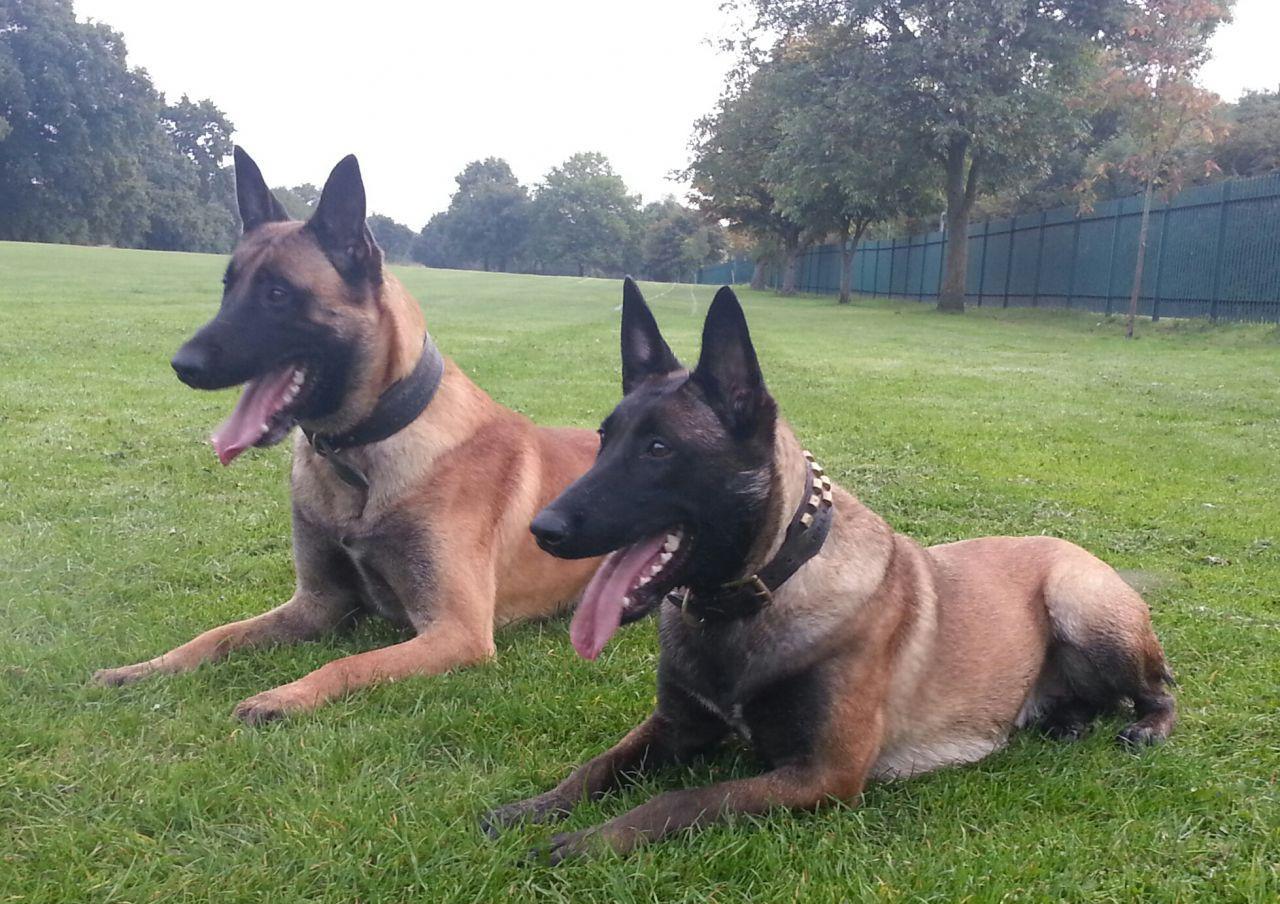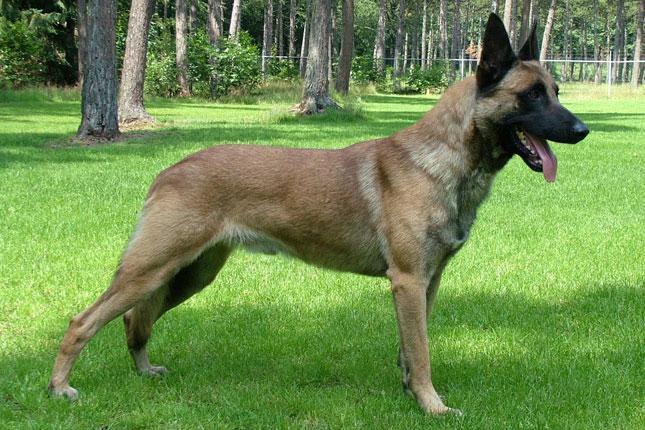The first image is the image on the left, the second image is the image on the right. Evaluate the accuracy of this statement regarding the images: "In one image od each pair a lone dog is standing still on grass.". Is it true? Answer yes or no. Yes. The first image is the image on the left, the second image is the image on the right. Assess this claim about the two images: "There is one dog standing still on all fours in the stacked position.". Correct or not? Answer yes or no. Yes. 